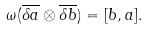Convert formula to latex. <formula><loc_0><loc_0><loc_500><loc_500>\omega ( \overline { \delta a } \otimes \overline { \delta b } ) = [ b , a ] .</formula> 